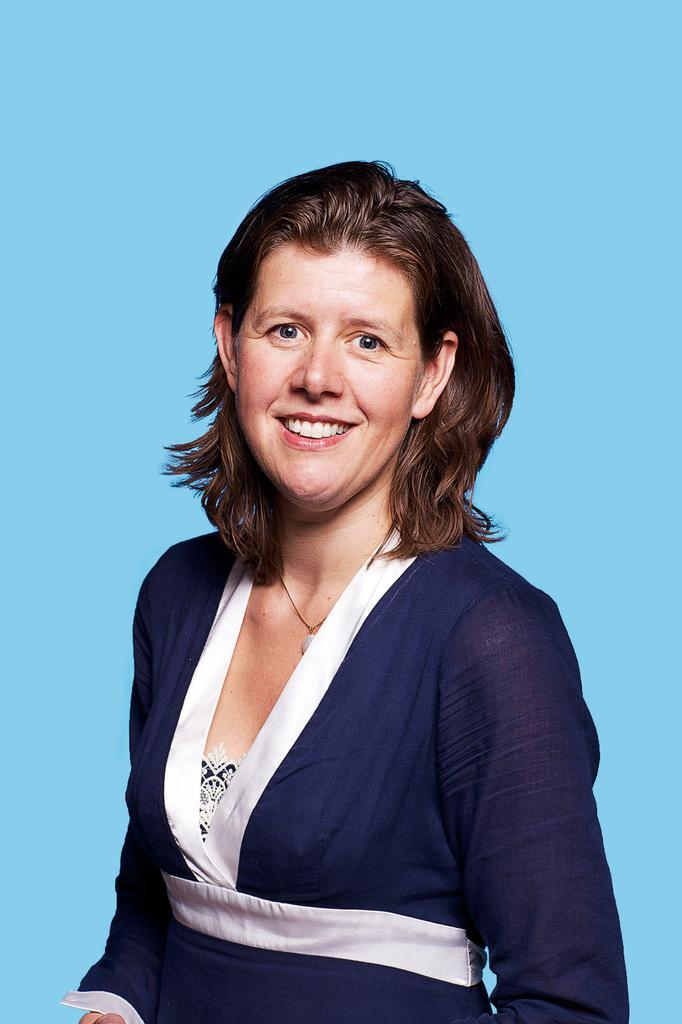Who is present in the image? There is a woman in the image. What is the woman's expression in the image? The woman is smiling in the image. What color is the background of the image? The background of the image is blue. What type of light is being used to illuminate the woman's invention in the image? There is no invention or light source present in the image; it only features a woman with a blue background. 